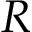<formula> <loc_0><loc_0><loc_500><loc_500>R</formula> 